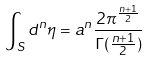Convert formula to latex. <formula><loc_0><loc_0><loc_500><loc_500>\int _ { S } { d ^ { n } } { \eta } = a ^ { n } \frac { 2 \pi ^ { \frac { n + 1 } { 2 } } } { \Gamma ( \frac { n + 1 } { 2 } ) }</formula> 